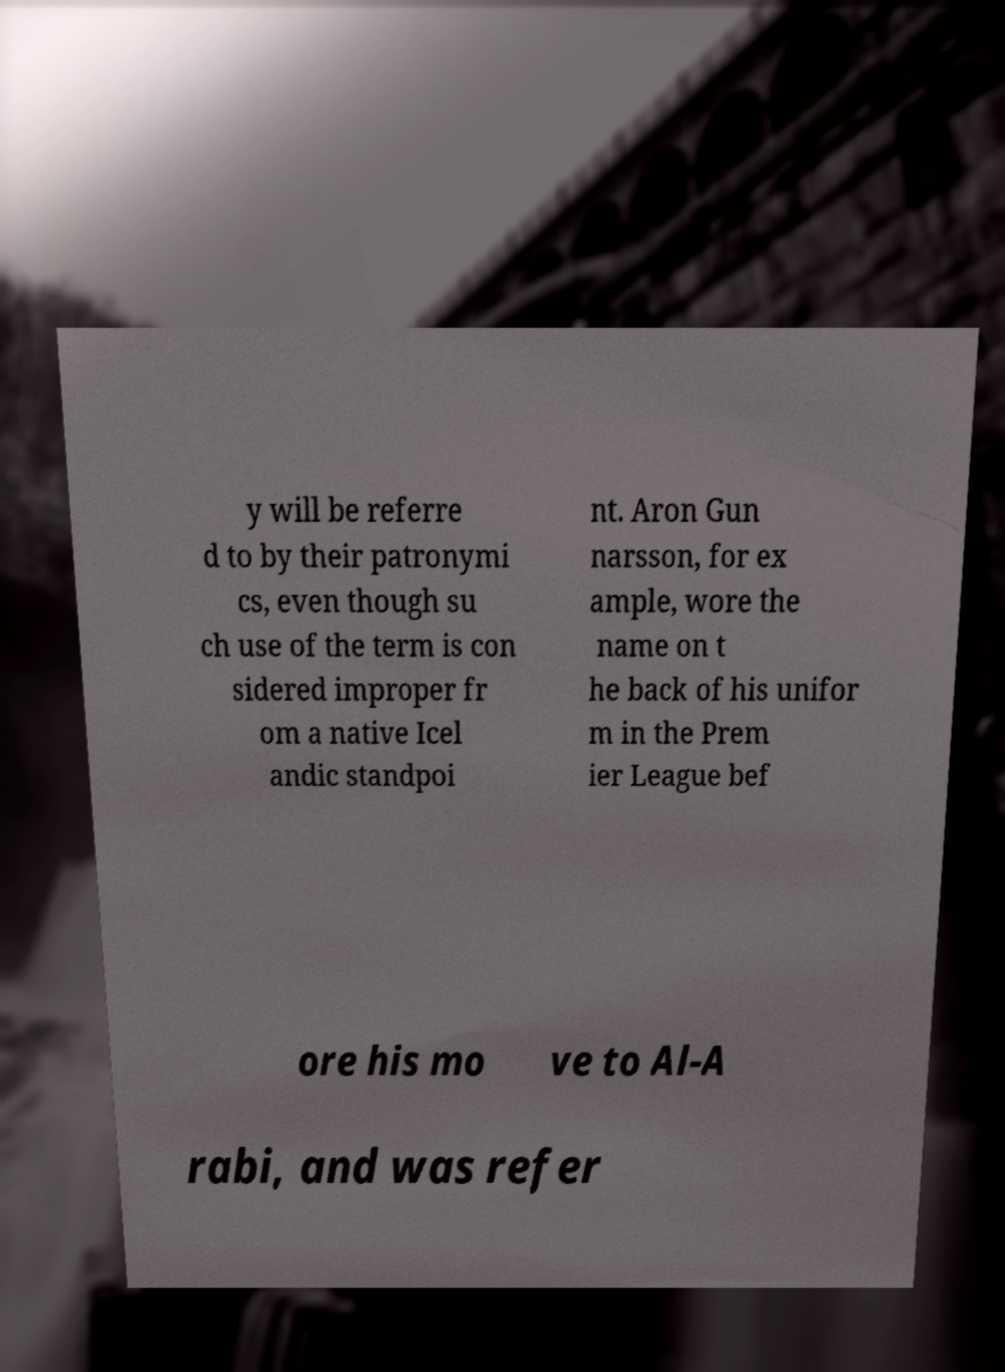Please read and relay the text visible in this image. What does it say? y will be referre d to by their patronymi cs, even though su ch use of the term is con sidered improper fr om a native Icel andic standpoi nt. Aron Gun narsson, for ex ample, wore the name on t he back of his unifor m in the Prem ier League bef ore his mo ve to Al-A rabi, and was refer 